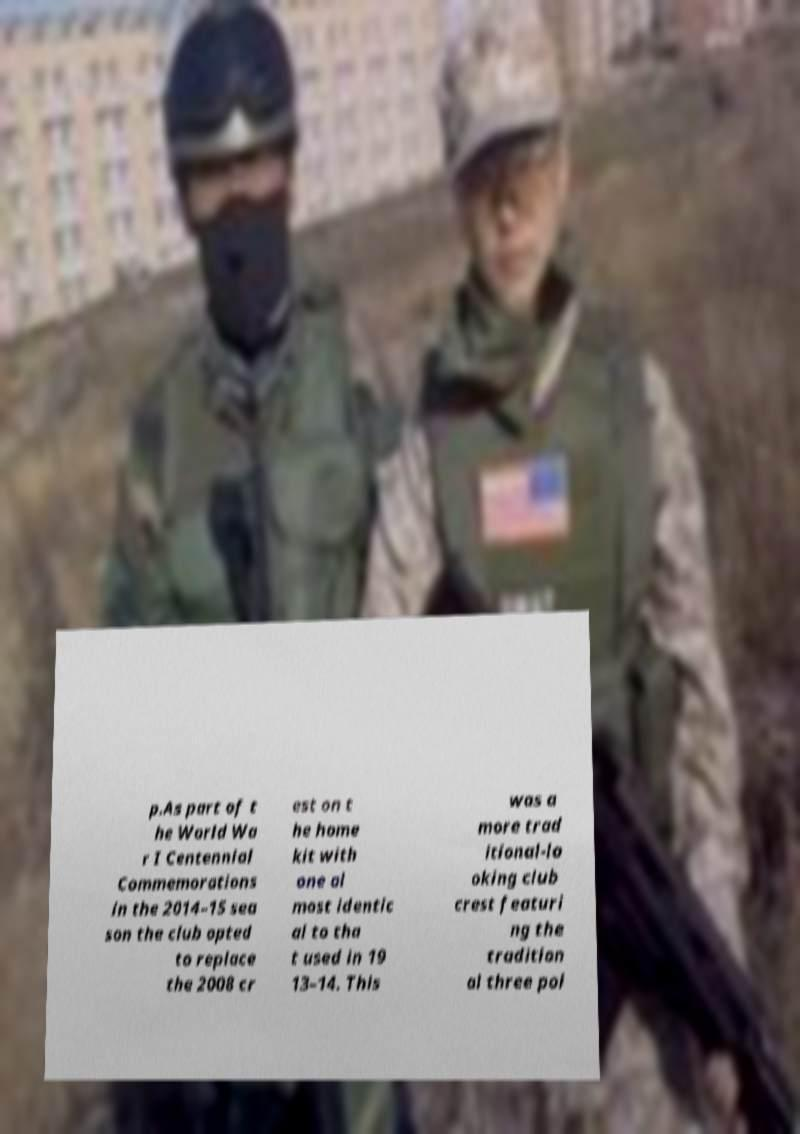Please read and relay the text visible in this image. What does it say? p.As part of t he World Wa r I Centennial Commemorations in the 2014–15 sea son the club opted to replace the 2008 cr est on t he home kit with one al most identic al to tha t used in 19 13–14. This was a more trad itional-lo oking club crest featuri ng the tradition al three poi 